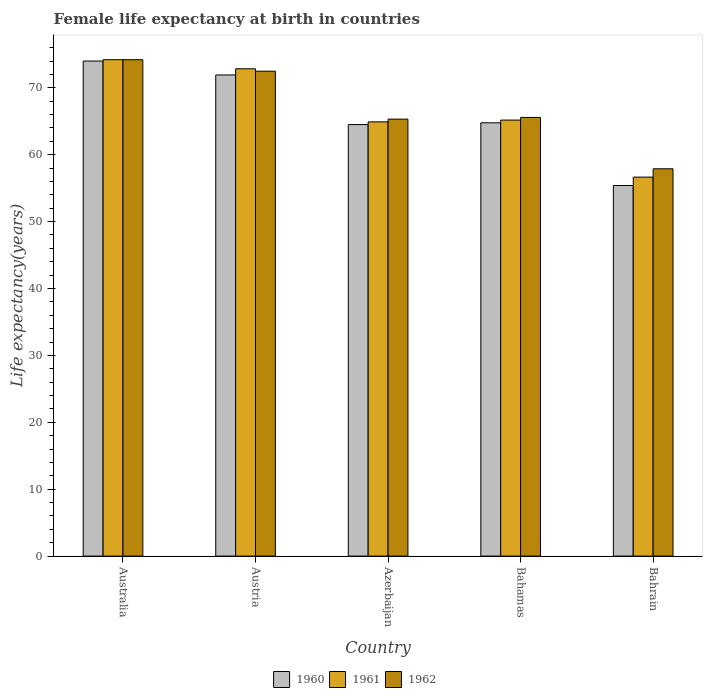How many different coloured bars are there?
Provide a succinct answer. 3. Are the number of bars on each tick of the X-axis equal?
Offer a terse response. Yes. How many bars are there on the 4th tick from the left?
Provide a short and direct response. 3. What is the label of the 1st group of bars from the left?
Your answer should be compact. Australia. In how many cases, is the number of bars for a given country not equal to the number of legend labels?
Provide a short and direct response. 0. What is the female life expectancy at birth in 1961 in Bahamas?
Your response must be concise. 65.17. Across all countries, what is the maximum female life expectancy at birth in 1961?
Provide a short and direct response. 74.2. Across all countries, what is the minimum female life expectancy at birth in 1960?
Provide a succinct answer. 55.39. In which country was the female life expectancy at birth in 1962 minimum?
Your answer should be very brief. Bahrain. What is the total female life expectancy at birth in 1961 in the graph?
Offer a terse response. 333.77. What is the difference between the female life expectancy at birth in 1961 in Australia and that in Bahrain?
Give a very brief answer. 17.55. What is the difference between the female life expectancy at birth in 1960 in Australia and the female life expectancy at birth in 1961 in Azerbaijan?
Your answer should be very brief. 9.09. What is the average female life expectancy at birth in 1961 per country?
Offer a very short reply. 66.75. What is the difference between the female life expectancy at birth of/in 1960 and female life expectancy at birth of/in 1961 in Bahamas?
Your answer should be very brief. -0.41. In how many countries, is the female life expectancy at birth in 1961 greater than 38 years?
Offer a terse response. 5. What is the ratio of the female life expectancy at birth in 1962 in Austria to that in Bahamas?
Offer a terse response. 1.11. Is the difference between the female life expectancy at birth in 1960 in Australia and Bahrain greater than the difference between the female life expectancy at birth in 1961 in Australia and Bahrain?
Give a very brief answer. Yes. What is the difference between the highest and the second highest female life expectancy at birth in 1961?
Provide a succinct answer. 7.67. What is the difference between the highest and the lowest female life expectancy at birth in 1960?
Your answer should be very brief. 18.61. In how many countries, is the female life expectancy at birth in 1960 greater than the average female life expectancy at birth in 1960 taken over all countries?
Keep it short and to the point. 2. Is the sum of the female life expectancy at birth in 1960 in Austria and Azerbaijan greater than the maximum female life expectancy at birth in 1961 across all countries?
Provide a short and direct response. Yes. What does the 2nd bar from the left in Austria represents?
Offer a terse response. 1961. What does the 3rd bar from the right in Bahamas represents?
Make the answer very short. 1960. Is it the case that in every country, the sum of the female life expectancy at birth in 1960 and female life expectancy at birth in 1962 is greater than the female life expectancy at birth in 1961?
Keep it short and to the point. Yes. How many bars are there?
Ensure brevity in your answer.  15. Are the values on the major ticks of Y-axis written in scientific E-notation?
Your answer should be very brief. No. Where does the legend appear in the graph?
Offer a very short reply. Bottom center. How many legend labels are there?
Offer a terse response. 3. What is the title of the graph?
Offer a terse response. Female life expectancy at birth in countries. What is the label or title of the X-axis?
Offer a terse response. Country. What is the label or title of the Y-axis?
Your answer should be very brief. Life expectancy(years). What is the Life expectancy(years) of 1960 in Australia?
Make the answer very short. 74. What is the Life expectancy(years) in 1961 in Australia?
Ensure brevity in your answer.  74.2. What is the Life expectancy(years) in 1962 in Australia?
Your answer should be compact. 74.2. What is the Life expectancy(years) of 1960 in Austria?
Offer a terse response. 71.92. What is the Life expectancy(years) in 1961 in Austria?
Ensure brevity in your answer.  72.84. What is the Life expectancy(years) of 1962 in Austria?
Keep it short and to the point. 72.48. What is the Life expectancy(years) in 1960 in Azerbaijan?
Your answer should be very brief. 64.5. What is the Life expectancy(years) of 1961 in Azerbaijan?
Provide a short and direct response. 64.91. What is the Life expectancy(years) in 1962 in Azerbaijan?
Offer a very short reply. 65.32. What is the Life expectancy(years) of 1960 in Bahamas?
Ensure brevity in your answer.  64.76. What is the Life expectancy(years) in 1961 in Bahamas?
Your answer should be very brief. 65.17. What is the Life expectancy(years) of 1962 in Bahamas?
Give a very brief answer. 65.57. What is the Life expectancy(years) of 1960 in Bahrain?
Give a very brief answer. 55.39. What is the Life expectancy(years) of 1961 in Bahrain?
Keep it short and to the point. 56.65. What is the Life expectancy(years) of 1962 in Bahrain?
Your answer should be very brief. 57.89. Across all countries, what is the maximum Life expectancy(years) in 1961?
Ensure brevity in your answer.  74.2. Across all countries, what is the maximum Life expectancy(years) in 1962?
Offer a very short reply. 74.2. Across all countries, what is the minimum Life expectancy(years) in 1960?
Your response must be concise. 55.39. Across all countries, what is the minimum Life expectancy(years) of 1961?
Your answer should be compact. 56.65. Across all countries, what is the minimum Life expectancy(years) in 1962?
Give a very brief answer. 57.89. What is the total Life expectancy(years) of 1960 in the graph?
Your answer should be compact. 330.58. What is the total Life expectancy(years) in 1961 in the graph?
Make the answer very short. 333.77. What is the total Life expectancy(years) in 1962 in the graph?
Offer a terse response. 335.46. What is the difference between the Life expectancy(years) of 1960 in Australia and that in Austria?
Give a very brief answer. 2.08. What is the difference between the Life expectancy(years) in 1961 in Australia and that in Austria?
Your answer should be very brief. 1.36. What is the difference between the Life expectancy(years) of 1962 in Australia and that in Austria?
Offer a terse response. 1.72. What is the difference between the Life expectancy(years) in 1960 in Australia and that in Azerbaijan?
Your answer should be compact. 9.5. What is the difference between the Life expectancy(years) of 1961 in Australia and that in Azerbaijan?
Make the answer very short. 9.29. What is the difference between the Life expectancy(years) of 1962 in Australia and that in Azerbaijan?
Offer a terse response. 8.88. What is the difference between the Life expectancy(years) of 1960 in Australia and that in Bahamas?
Your response must be concise. 9.24. What is the difference between the Life expectancy(years) of 1961 in Australia and that in Bahamas?
Make the answer very short. 9.03. What is the difference between the Life expectancy(years) of 1962 in Australia and that in Bahamas?
Offer a very short reply. 8.63. What is the difference between the Life expectancy(years) of 1960 in Australia and that in Bahrain?
Your response must be concise. 18.61. What is the difference between the Life expectancy(years) in 1961 in Australia and that in Bahrain?
Keep it short and to the point. 17.55. What is the difference between the Life expectancy(years) of 1962 in Australia and that in Bahrain?
Your answer should be very brief. 16.31. What is the difference between the Life expectancy(years) of 1960 in Austria and that in Azerbaijan?
Your answer should be compact. 7.42. What is the difference between the Life expectancy(years) of 1961 in Austria and that in Azerbaijan?
Your response must be concise. 7.93. What is the difference between the Life expectancy(years) of 1962 in Austria and that in Azerbaijan?
Keep it short and to the point. 7.16. What is the difference between the Life expectancy(years) in 1960 in Austria and that in Bahamas?
Your answer should be very brief. 7.16. What is the difference between the Life expectancy(years) in 1961 in Austria and that in Bahamas?
Keep it short and to the point. 7.67. What is the difference between the Life expectancy(years) of 1962 in Austria and that in Bahamas?
Ensure brevity in your answer.  6.91. What is the difference between the Life expectancy(years) in 1960 in Austria and that in Bahrain?
Your answer should be compact. 16.53. What is the difference between the Life expectancy(years) of 1961 in Austria and that in Bahrain?
Your answer should be compact. 16.19. What is the difference between the Life expectancy(years) of 1962 in Austria and that in Bahrain?
Give a very brief answer. 14.59. What is the difference between the Life expectancy(years) of 1960 in Azerbaijan and that in Bahamas?
Keep it short and to the point. -0.26. What is the difference between the Life expectancy(years) in 1961 in Azerbaijan and that in Bahamas?
Ensure brevity in your answer.  -0.27. What is the difference between the Life expectancy(years) in 1962 in Azerbaijan and that in Bahamas?
Offer a very short reply. -0.25. What is the difference between the Life expectancy(years) of 1960 in Azerbaijan and that in Bahrain?
Offer a terse response. 9.11. What is the difference between the Life expectancy(years) in 1961 in Azerbaijan and that in Bahrain?
Provide a succinct answer. 8.26. What is the difference between the Life expectancy(years) of 1962 in Azerbaijan and that in Bahrain?
Your answer should be compact. 7.42. What is the difference between the Life expectancy(years) of 1960 in Bahamas and that in Bahrain?
Offer a terse response. 9.37. What is the difference between the Life expectancy(years) of 1961 in Bahamas and that in Bahrain?
Keep it short and to the point. 8.52. What is the difference between the Life expectancy(years) of 1962 in Bahamas and that in Bahrain?
Make the answer very short. 7.68. What is the difference between the Life expectancy(years) of 1960 in Australia and the Life expectancy(years) of 1961 in Austria?
Ensure brevity in your answer.  1.16. What is the difference between the Life expectancy(years) in 1960 in Australia and the Life expectancy(years) in 1962 in Austria?
Offer a very short reply. 1.52. What is the difference between the Life expectancy(years) of 1961 in Australia and the Life expectancy(years) of 1962 in Austria?
Give a very brief answer. 1.72. What is the difference between the Life expectancy(years) of 1960 in Australia and the Life expectancy(years) of 1961 in Azerbaijan?
Your answer should be compact. 9.09. What is the difference between the Life expectancy(years) of 1960 in Australia and the Life expectancy(years) of 1962 in Azerbaijan?
Your answer should be compact. 8.68. What is the difference between the Life expectancy(years) in 1961 in Australia and the Life expectancy(years) in 1962 in Azerbaijan?
Your answer should be very brief. 8.88. What is the difference between the Life expectancy(years) in 1960 in Australia and the Life expectancy(years) in 1961 in Bahamas?
Your response must be concise. 8.83. What is the difference between the Life expectancy(years) in 1960 in Australia and the Life expectancy(years) in 1962 in Bahamas?
Make the answer very short. 8.43. What is the difference between the Life expectancy(years) of 1961 in Australia and the Life expectancy(years) of 1962 in Bahamas?
Give a very brief answer. 8.63. What is the difference between the Life expectancy(years) in 1960 in Australia and the Life expectancy(years) in 1961 in Bahrain?
Provide a short and direct response. 17.35. What is the difference between the Life expectancy(years) in 1960 in Australia and the Life expectancy(years) in 1962 in Bahrain?
Your answer should be compact. 16.11. What is the difference between the Life expectancy(years) of 1961 in Australia and the Life expectancy(years) of 1962 in Bahrain?
Provide a succinct answer. 16.31. What is the difference between the Life expectancy(years) of 1960 in Austria and the Life expectancy(years) of 1961 in Azerbaijan?
Make the answer very short. 7.01. What is the difference between the Life expectancy(years) in 1960 in Austria and the Life expectancy(years) in 1962 in Azerbaijan?
Ensure brevity in your answer.  6.6. What is the difference between the Life expectancy(years) in 1961 in Austria and the Life expectancy(years) in 1962 in Azerbaijan?
Your response must be concise. 7.52. What is the difference between the Life expectancy(years) in 1960 in Austria and the Life expectancy(years) in 1961 in Bahamas?
Keep it short and to the point. 6.75. What is the difference between the Life expectancy(years) of 1960 in Austria and the Life expectancy(years) of 1962 in Bahamas?
Keep it short and to the point. 6.35. What is the difference between the Life expectancy(years) in 1961 in Austria and the Life expectancy(years) in 1962 in Bahamas?
Offer a very short reply. 7.27. What is the difference between the Life expectancy(years) of 1960 in Austria and the Life expectancy(years) of 1961 in Bahrain?
Offer a terse response. 15.27. What is the difference between the Life expectancy(years) of 1960 in Austria and the Life expectancy(years) of 1962 in Bahrain?
Give a very brief answer. 14.03. What is the difference between the Life expectancy(years) in 1961 in Austria and the Life expectancy(years) in 1962 in Bahrain?
Keep it short and to the point. 14.95. What is the difference between the Life expectancy(years) of 1960 in Azerbaijan and the Life expectancy(years) of 1961 in Bahamas?
Your answer should be very brief. -0.67. What is the difference between the Life expectancy(years) in 1960 in Azerbaijan and the Life expectancy(years) in 1962 in Bahamas?
Your answer should be very brief. -1.07. What is the difference between the Life expectancy(years) in 1961 in Azerbaijan and the Life expectancy(years) in 1962 in Bahamas?
Offer a very short reply. -0.66. What is the difference between the Life expectancy(years) of 1960 in Azerbaijan and the Life expectancy(years) of 1961 in Bahrain?
Make the answer very short. 7.85. What is the difference between the Life expectancy(years) of 1960 in Azerbaijan and the Life expectancy(years) of 1962 in Bahrain?
Make the answer very short. 6.61. What is the difference between the Life expectancy(years) in 1961 in Azerbaijan and the Life expectancy(years) in 1962 in Bahrain?
Provide a short and direct response. 7.01. What is the difference between the Life expectancy(years) of 1960 in Bahamas and the Life expectancy(years) of 1961 in Bahrain?
Give a very brief answer. 8.11. What is the difference between the Life expectancy(years) of 1960 in Bahamas and the Life expectancy(years) of 1962 in Bahrain?
Offer a very short reply. 6.87. What is the difference between the Life expectancy(years) in 1961 in Bahamas and the Life expectancy(years) in 1962 in Bahrain?
Your answer should be compact. 7.28. What is the average Life expectancy(years) of 1960 per country?
Ensure brevity in your answer.  66.12. What is the average Life expectancy(years) of 1961 per country?
Your answer should be compact. 66.75. What is the average Life expectancy(years) of 1962 per country?
Ensure brevity in your answer.  67.09. What is the difference between the Life expectancy(years) of 1960 and Life expectancy(years) of 1962 in Australia?
Your answer should be very brief. -0.2. What is the difference between the Life expectancy(years) in 1961 and Life expectancy(years) in 1962 in Australia?
Provide a short and direct response. 0. What is the difference between the Life expectancy(years) of 1960 and Life expectancy(years) of 1961 in Austria?
Keep it short and to the point. -0.92. What is the difference between the Life expectancy(years) in 1960 and Life expectancy(years) in 1962 in Austria?
Provide a succinct answer. -0.56. What is the difference between the Life expectancy(years) in 1961 and Life expectancy(years) in 1962 in Austria?
Ensure brevity in your answer.  0.36. What is the difference between the Life expectancy(years) of 1960 and Life expectancy(years) of 1961 in Azerbaijan?
Ensure brevity in your answer.  -0.41. What is the difference between the Life expectancy(years) of 1960 and Life expectancy(years) of 1962 in Azerbaijan?
Make the answer very short. -0.81. What is the difference between the Life expectancy(years) of 1961 and Life expectancy(years) of 1962 in Azerbaijan?
Offer a terse response. -0.41. What is the difference between the Life expectancy(years) in 1960 and Life expectancy(years) in 1961 in Bahamas?
Keep it short and to the point. -0.41. What is the difference between the Life expectancy(years) in 1960 and Life expectancy(years) in 1962 in Bahamas?
Ensure brevity in your answer.  -0.81. What is the difference between the Life expectancy(years) in 1961 and Life expectancy(years) in 1962 in Bahamas?
Give a very brief answer. -0.4. What is the difference between the Life expectancy(years) of 1960 and Life expectancy(years) of 1961 in Bahrain?
Keep it short and to the point. -1.26. What is the difference between the Life expectancy(years) in 1960 and Life expectancy(years) in 1962 in Bahrain?
Your response must be concise. -2.5. What is the difference between the Life expectancy(years) of 1961 and Life expectancy(years) of 1962 in Bahrain?
Provide a succinct answer. -1.24. What is the ratio of the Life expectancy(years) of 1960 in Australia to that in Austria?
Offer a very short reply. 1.03. What is the ratio of the Life expectancy(years) in 1961 in Australia to that in Austria?
Offer a terse response. 1.02. What is the ratio of the Life expectancy(years) of 1962 in Australia to that in Austria?
Keep it short and to the point. 1.02. What is the ratio of the Life expectancy(years) of 1960 in Australia to that in Azerbaijan?
Give a very brief answer. 1.15. What is the ratio of the Life expectancy(years) in 1961 in Australia to that in Azerbaijan?
Your answer should be compact. 1.14. What is the ratio of the Life expectancy(years) in 1962 in Australia to that in Azerbaijan?
Your answer should be very brief. 1.14. What is the ratio of the Life expectancy(years) in 1960 in Australia to that in Bahamas?
Make the answer very short. 1.14. What is the ratio of the Life expectancy(years) in 1961 in Australia to that in Bahamas?
Your answer should be very brief. 1.14. What is the ratio of the Life expectancy(years) of 1962 in Australia to that in Bahamas?
Offer a very short reply. 1.13. What is the ratio of the Life expectancy(years) in 1960 in Australia to that in Bahrain?
Ensure brevity in your answer.  1.34. What is the ratio of the Life expectancy(years) in 1961 in Australia to that in Bahrain?
Your response must be concise. 1.31. What is the ratio of the Life expectancy(years) in 1962 in Australia to that in Bahrain?
Keep it short and to the point. 1.28. What is the ratio of the Life expectancy(years) in 1960 in Austria to that in Azerbaijan?
Provide a succinct answer. 1.11. What is the ratio of the Life expectancy(years) in 1961 in Austria to that in Azerbaijan?
Provide a short and direct response. 1.12. What is the ratio of the Life expectancy(years) of 1962 in Austria to that in Azerbaijan?
Keep it short and to the point. 1.11. What is the ratio of the Life expectancy(years) of 1960 in Austria to that in Bahamas?
Ensure brevity in your answer.  1.11. What is the ratio of the Life expectancy(years) in 1961 in Austria to that in Bahamas?
Offer a very short reply. 1.12. What is the ratio of the Life expectancy(years) of 1962 in Austria to that in Bahamas?
Make the answer very short. 1.11. What is the ratio of the Life expectancy(years) in 1960 in Austria to that in Bahrain?
Offer a very short reply. 1.3. What is the ratio of the Life expectancy(years) of 1961 in Austria to that in Bahrain?
Provide a short and direct response. 1.29. What is the ratio of the Life expectancy(years) in 1962 in Austria to that in Bahrain?
Offer a terse response. 1.25. What is the ratio of the Life expectancy(years) in 1960 in Azerbaijan to that in Bahamas?
Ensure brevity in your answer.  1. What is the ratio of the Life expectancy(years) of 1961 in Azerbaijan to that in Bahamas?
Make the answer very short. 1. What is the ratio of the Life expectancy(years) in 1960 in Azerbaijan to that in Bahrain?
Ensure brevity in your answer.  1.16. What is the ratio of the Life expectancy(years) of 1961 in Azerbaijan to that in Bahrain?
Your answer should be very brief. 1.15. What is the ratio of the Life expectancy(years) of 1962 in Azerbaijan to that in Bahrain?
Make the answer very short. 1.13. What is the ratio of the Life expectancy(years) of 1960 in Bahamas to that in Bahrain?
Offer a very short reply. 1.17. What is the ratio of the Life expectancy(years) in 1961 in Bahamas to that in Bahrain?
Provide a succinct answer. 1.15. What is the ratio of the Life expectancy(years) in 1962 in Bahamas to that in Bahrain?
Ensure brevity in your answer.  1.13. What is the difference between the highest and the second highest Life expectancy(years) in 1960?
Your answer should be compact. 2.08. What is the difference between the highest and the second highest Life expectancy(years) of 1961?
Keep it short and to the point. 1.36. What is the difference between the highest and the second highest Life expectancy(years) in 1962?
Offer a very short reply. 1.72. What is the difference between the highest and the lowest Life expectancy(years) of 1960?
Offer a terse response. 18.61. What is the difference between the highest and the lowest Life expectancy(years) in 1961?
Give a very brief answer. 17.55. What is the difference between the highest and the lowest Life expectancy(years) of 1962?
Your answer should be compact. 16.31. 